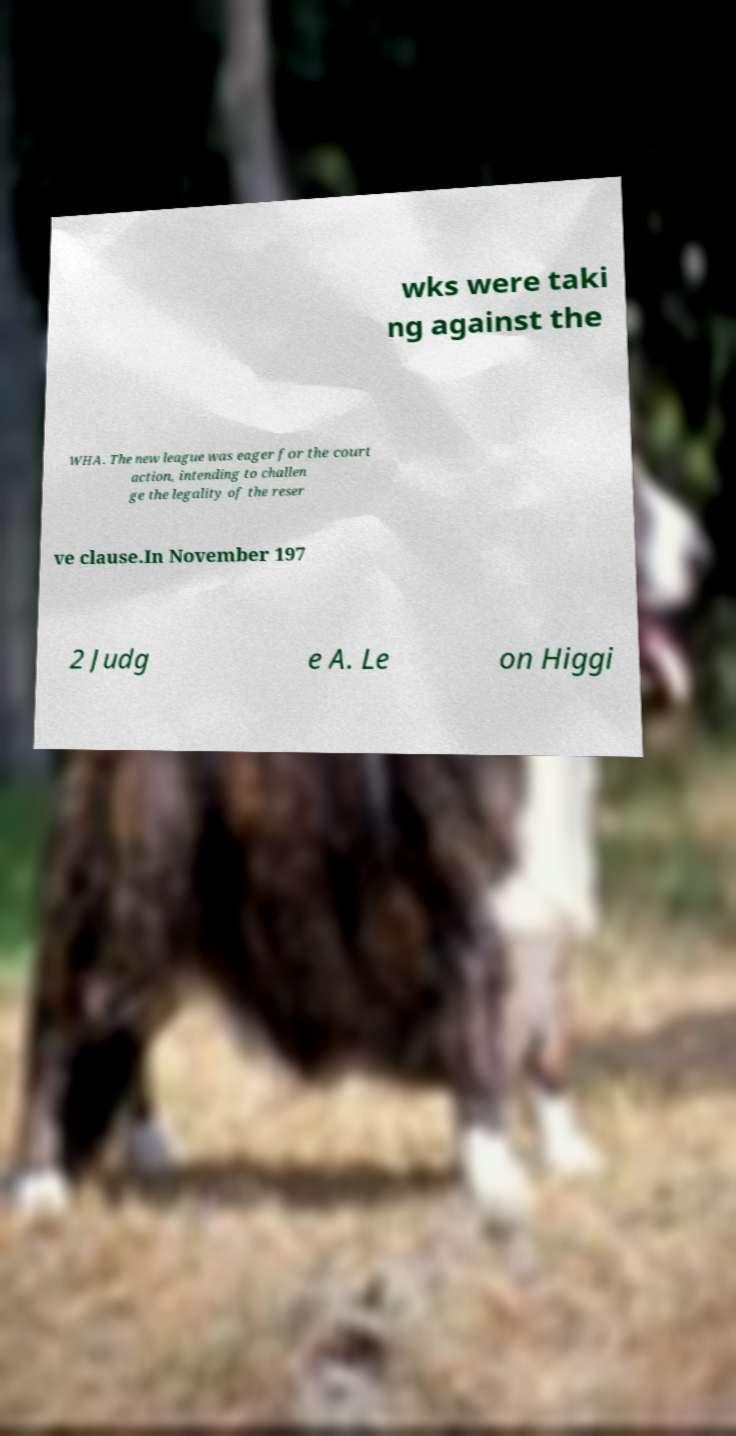Please read and relay the text visible in this image. What does it say? wks were taki ng against the WHA. The new league was eager for the court action, intending to challen ge the legality of the reser ve clause.In November 197 2 Judg e A. Le on Higgi 